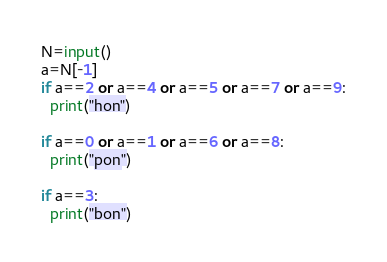<code> <loc_0><loc_0><loc_500><loc_500><_Python_>N=input()
a=N[-1]
if a==2 or a==4 or a==5 or a==7 or a==9:
  print("hon")

if a==0 or a==1 or a==6 or a==8:
  print("pon")

if a==3:
  print("bon")</code> 